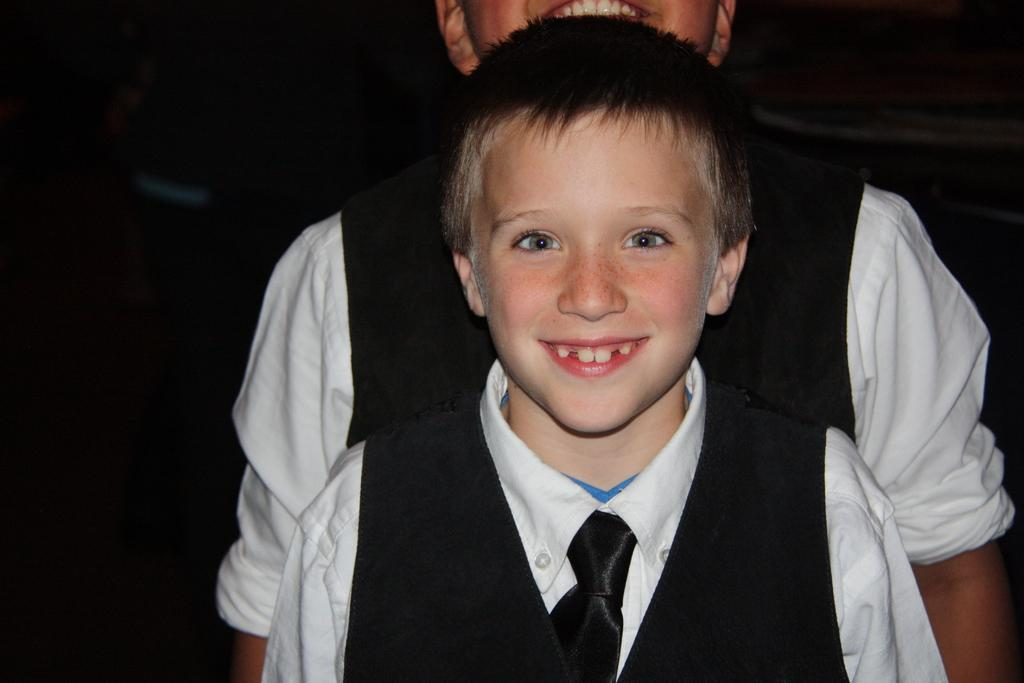What is the main subject in the foreground of the image? There is a boy in the foreground of the image. Can you describe the position of the second boy in the image? There is another boy behind the first boy in the image. What type of swing can be seen in the image? There is no swing present in the image. What is the man doing in the image? There is no man present in the image. 